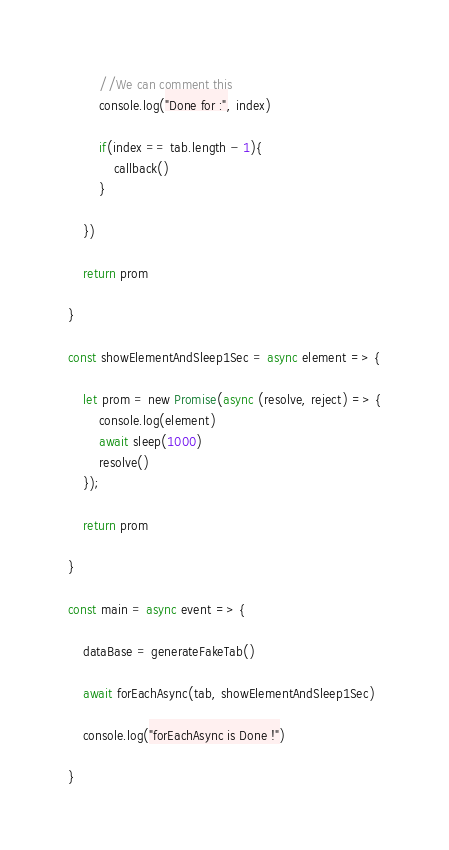Convert code to text. <code><loc_0><loc_0><loc_500><loc_500><_JavaScript_>
		//We can comment this
		console.log("Done for :", index)

		if(index == tab.length - 1){
			callback()
		}

	})

	return prom

}

const showElementAndSleep1Sec = async element => {

	let prom = new Promise(async (resolve, reject) => {
		console.log(element)
		await sleep(1000)
		resolve()
	});

	return prom

}

const main = async event => {

	dataBase = generateFakeTab()

	await forEachAsync(tab, showElementAndSleep1Sec)

	console.log("forEachAsync is Done !")

}
</code> 